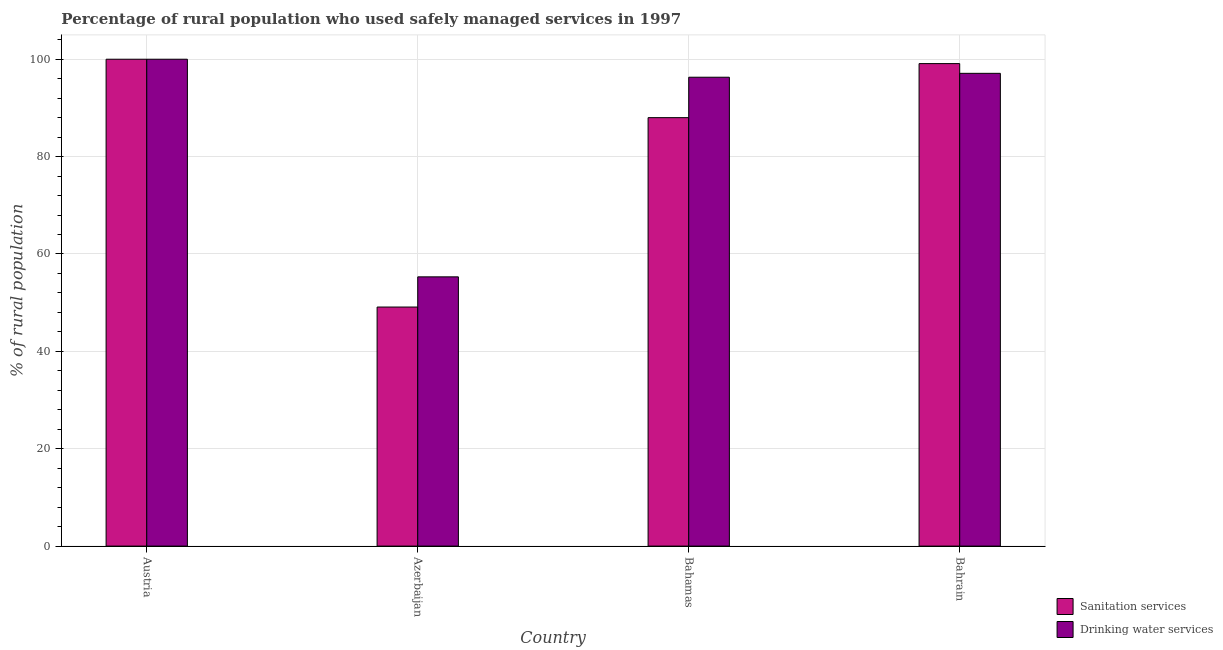How many different coloured bars are there?
Provide a succinct answer. 2. In how many cases, is the number of bars for a given country not equal to the number of legend labels?
Your response must be concise. 0. What is the percentage of rural population who used sanitation services in Bahrain?
Keep it short and to the point. 99.1. Across all countries, what is the minimum percentage of rural population who used drinking water services?
Offer a very short reply. 55.3. In which country was the percentage of rural population who used sanitation services maximum?
Your answer should be very brief. Austria. In which country was the percentage of rural population who used sanitation services minimum?
Your response must be concise. Azerbaijan. What is the total percentage of rural population who used sanitation services in the graph?
Offer a terse response. 336.2. What is the difference between the percentage of rural population who used drinking water services in Bahrain and the percentage of rural population who used sanitation services in Austria?
Ensure brevity in your answer.  -2.9. What is the average percentage of rural population who used sanitation services per country?
Your answer should be very brief. 84.05. In how many countries, is the percentage of rural population who used sanitation services greater than 20 %?
Your answer should be compact. 4. What is the ratio of the percentage of rural population who used sanitation services in Austria to that in Bahamas?
Offer a terse response. 1.14. Is the percentage of rural population who used drinking water services in Austria less than that in Bahamas?
Your answer should be compact. No. What is the difference between the highest and the second highest percentage of rural population who used drinking water services?
Make the answer very short. 2.9. What is the difference between the highest and the lowest percentage of rural population who used drinking water services?
Your response must be concise. 44.7. What does the 1st bar from the left in Bahamas represents?
Ensure brevity in your answer.  Sanitation services. What does the 2nd bar from the right in Bahrain represents?
Offer a terse response. Sanitation services. Are the values on the major ticks of Y-axis written in scientific E-notation?
Your answer should be very brief. No. Does the graph contain grids?
Make the answer very short. Yes. Where does the legend appear in the graph?
Offer a terse response. Bottom right. How many legend labels are there?
Your response must be concise. 2. What is the title of the graph?
Your answer should be compact. Percentage of rural population who used safely managed services in 1997. What is the label or title of the X-axis?
Offer a very short reply. Country. What is the label or title of the Y-axis?
Your answer should be compact. % of rural population. What is the % of rural population of Sanitation services in Austria?
Ensure brevity in your answer.  100. What is the % of rural population of Sanitation services in Azerbaijan?
Make the answer very short. 49.1. What is the % of rural population in Drinking water services in Azerbaijan?
Offer a terse response. 55.3. What is the % of rural population of Sanitation services in Bahamas?
Give a very brief answer. 88. What is the % of rural population in Drinking water services in Bahamas?
Your answer should be very brief. 96.3. What is the % of rural population in Sanitation services in Bahrain?
Ensure brevity in your answer.  99.1. What is the % of rural population of Drinking water services in Bahrain?
Provide a succinct answer. 97.1. Across all countries, what is the maximum % of rural population in Sanitation services?
Make the answer very short. 100. Across all countries, what is the minimum % of rural population of Sanitation services?
Your response must be concise. 49.1. Across all countries, what is the minimum % of rural population in Drinking water services?
Provide a short and direct response. 55.3. What is the total % of rural population of Sanitation services in the graph?
Ensure brevity in your answer.  336.2. What is the total % of rural population of Drinking water services in the graph?
Your answer should be compact. 348.7. What is the difference between the % of rural population in Sanitation services in Austria and that in Azerbaijan?
Offer a very short reply. 50.9. What is the difference between the % of rural population in Drinking water services in Austria and that in Azerbaijan?
Offer a very short reply. 44.7. What is the difference between the % of rural population in Sanitation services in Austria and that in Bahrain?
Make the answer very short. 0.9. What is the difference between the % of rural population of Sanitation services in Azerbaijan and that in Bahamas?
Keep it short and to the point. -38.9. What is the difference between the % of rural population of Drinking water services in Azerbaijan and that in Bahamas?
Provide a succinct answer. -41. What is the difference between the % of rural population of Drinking water services in Azerbaijan and that in Bahrain?
Your answer should be compact. -41.8. What is the difference between the % of rural population in Drinking water services in Bahamas and that in Bahrain?
Provide a short and direct response. -0.8. What is the difference between the % of rural population in Sanitation services in Austria and the % of rural population in Drinking water services in Azerbaijan?
Provide a short and direct response. 44.7. What is the difference between the % of rural population in Sanitation services in Azerbaijan and the % of rural population in Drinking water services in Bahamas?
Give a very brief answer. -47.2. What is the difference between the % of rural population in Sanitation services in Azerbaijan and the % of rural population in Drinking water services in Bahrain?
Give a very brief answer. -48. What is the average % of rural population of Sanitation services per country?
Ensure brevity in your answer.  84.05. What is the average % of rural population of Drinking water services per country?
Your answer should be compact. 87.17. What is the difference between the % of rural population in Sanitation services and % of rural population in Drinking water services in Azerbaijan?
Give a very brief answer. -6.2. What is the difference between the % of rural population of Sanitation services and % of rural population of Drinking water services in Bahamas?
Provide a short and direct response. -8.3. What is the difference between the % of rural population in Sanitation services and % of rural population in Drinking water services in Bahrain?
Offer a terse response. 2. What is the ratio of the % of rural population in Sanitation services in Austria to that in Azerbaijan?
Provide a short and direct response. 2.04. What is the ratio of the % of rural population of Drinking water services in Austria to that in Azerbaijan?
Provide a succinct answer. 1.81. What is the ratio of the % of rural population of Sanitation services in Austria to that in Bahamas?
Offer a terse response. 1.14. What is the ratio of the % of rural population in Drinking water services in Austria to that in Bahamas?
Offer a terse response. 1.04. What is the ratio of the % of rural population in Sanitation services in Austria to that in Bahrain?
Keep it short and to the point. 1.01. What is the ratio of the % of rural population in Drinking water services in Austria to that in Bahrain?
Keep it short and to the point. 1.03. What is the ratio of the % of rural population in Sanitation services in Azerbaijan to that in Bahamas?
Provide a succinct answer. 0.56. What is the ratio of the % of rural population in Drinking water services in Azerbaijan to that in Bahamas?
Keep it short and to the point. 0.57. What is the ratio of the % of rural population of Sanitation services in Azerbaijan to that in Bahrain?
Make the answer very short. 0.5. What is the ratio of the % of rural population of Drinking water services in Azerbaijan to that in Bahrain?
Make the answer very short. 0.57. What is the ratio of the % of rural population of Sanitation services in Bahamas to that in Bahrain?
Provide a succinct answer. 0.89. What is the ratio of the % of rural population in Drinking water services in Bahamas to that in Bahrain?
Your answer should be compact. 0.99. What is the difference between the highest and the second highest % of rural population in Sanitation services?
Your response must be concise. 0.9. What is the difference between the highest and the lowest % of rural population in Sanitation services?
Provide a succinct answer. 50.9. What is the difference between the highest and the lowest % of rural population of Drinking water services?
Your answer should be compact. 44.7. 